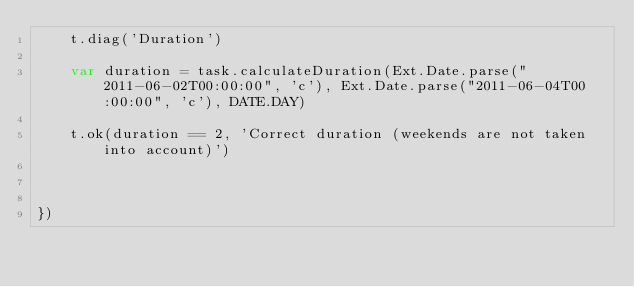Convert code to text. <code><loc_0><loc_0><loc_500><loc_500><_JavaScript_>    t.diag('Duration')
    
    var duration = task.calculateDuration(Ext.Date.parse("2011-06-02T00:00:00", 'c'), Ext.Date.parse("2011-06-04T00:00:00", 'c'), DATE.DAY)
    
    t.ok(duration == 2, 'Correct duration (weekends are not taken into account)')
    
    
    
})    
</code> 